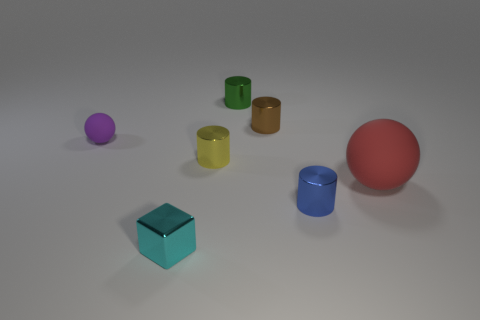The object that is both in front of the large sphere and on the right side of the brown thing has what shape?
Offer a terse response. Cylinder. What number of things are blue metallic things or tiny blue shiny cylinders that are in front of the yellow cylinder?
Your answer should be very brief. 1. Is the material of the red object the same as the small sphere?
Your response must be concise. Yes. What number of other things are the same shape as the tiny brown object?
Make the answer very short. 3. What is the size of the thing that is behind the small blue cylinder and in front of the yellow metal cylinder?
Your answer should be compact. Large. How many matte things are tiny balls or big yellow things?
Make the answer very short. 1. There is a rubber thing behind the yellow cylinder; is its shape the same as the matte thing right of the green cylinder?
Your answer should be compact. Yes. Are there any yellow cylinders made of the same material as the small blue cylinder?
Make the answer very short. Yes. What color is the large thing?
Give a very brief answer. Red. How big is the metallic cylinder that is in front of the tiny yellow object?
Your answer should be very brief. Small. 